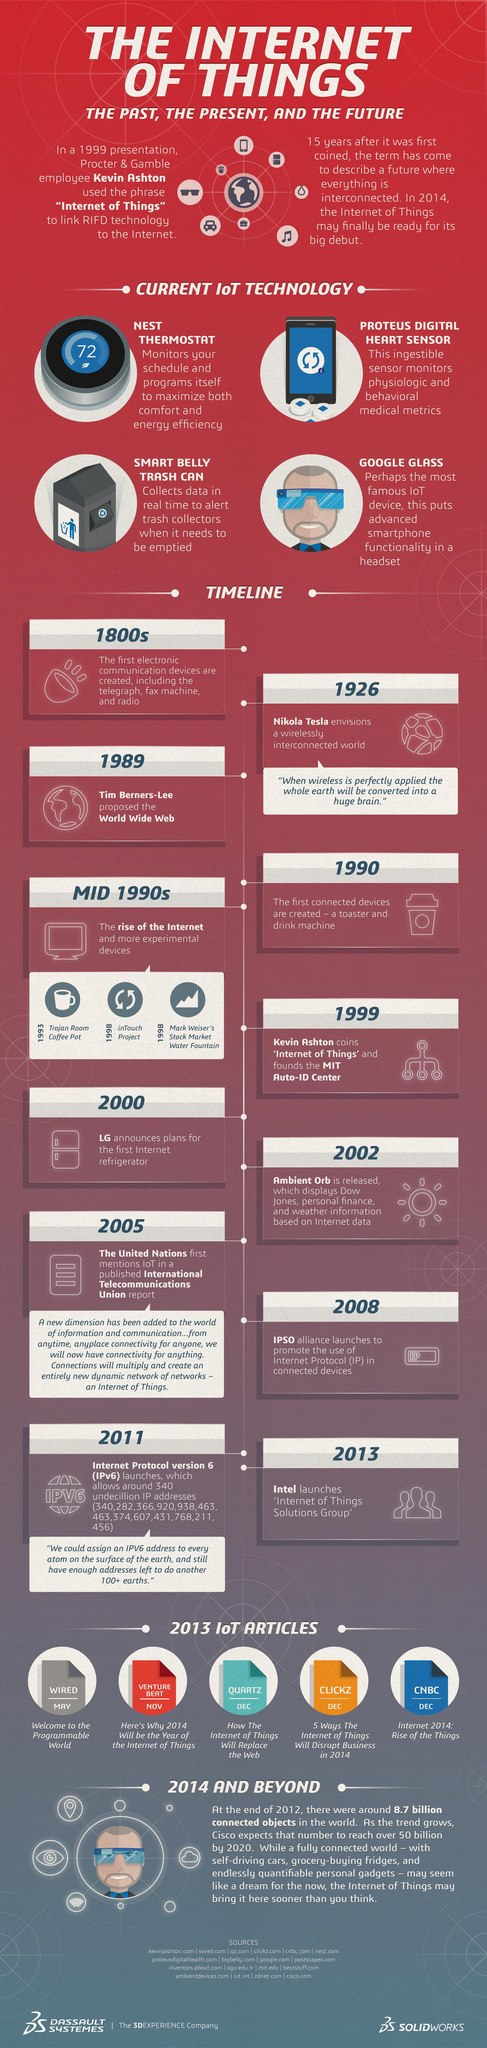In which year Internet protocol version 6 launched?
Answer the question with a short phrase. 2011 What is the name of the most famous IoT device? Google Glass How many Ip addresses mentioned in this infographic? 13 The telegraph invented in Which year? 1800s How many IoT articles mentioned in this infographic? 5 